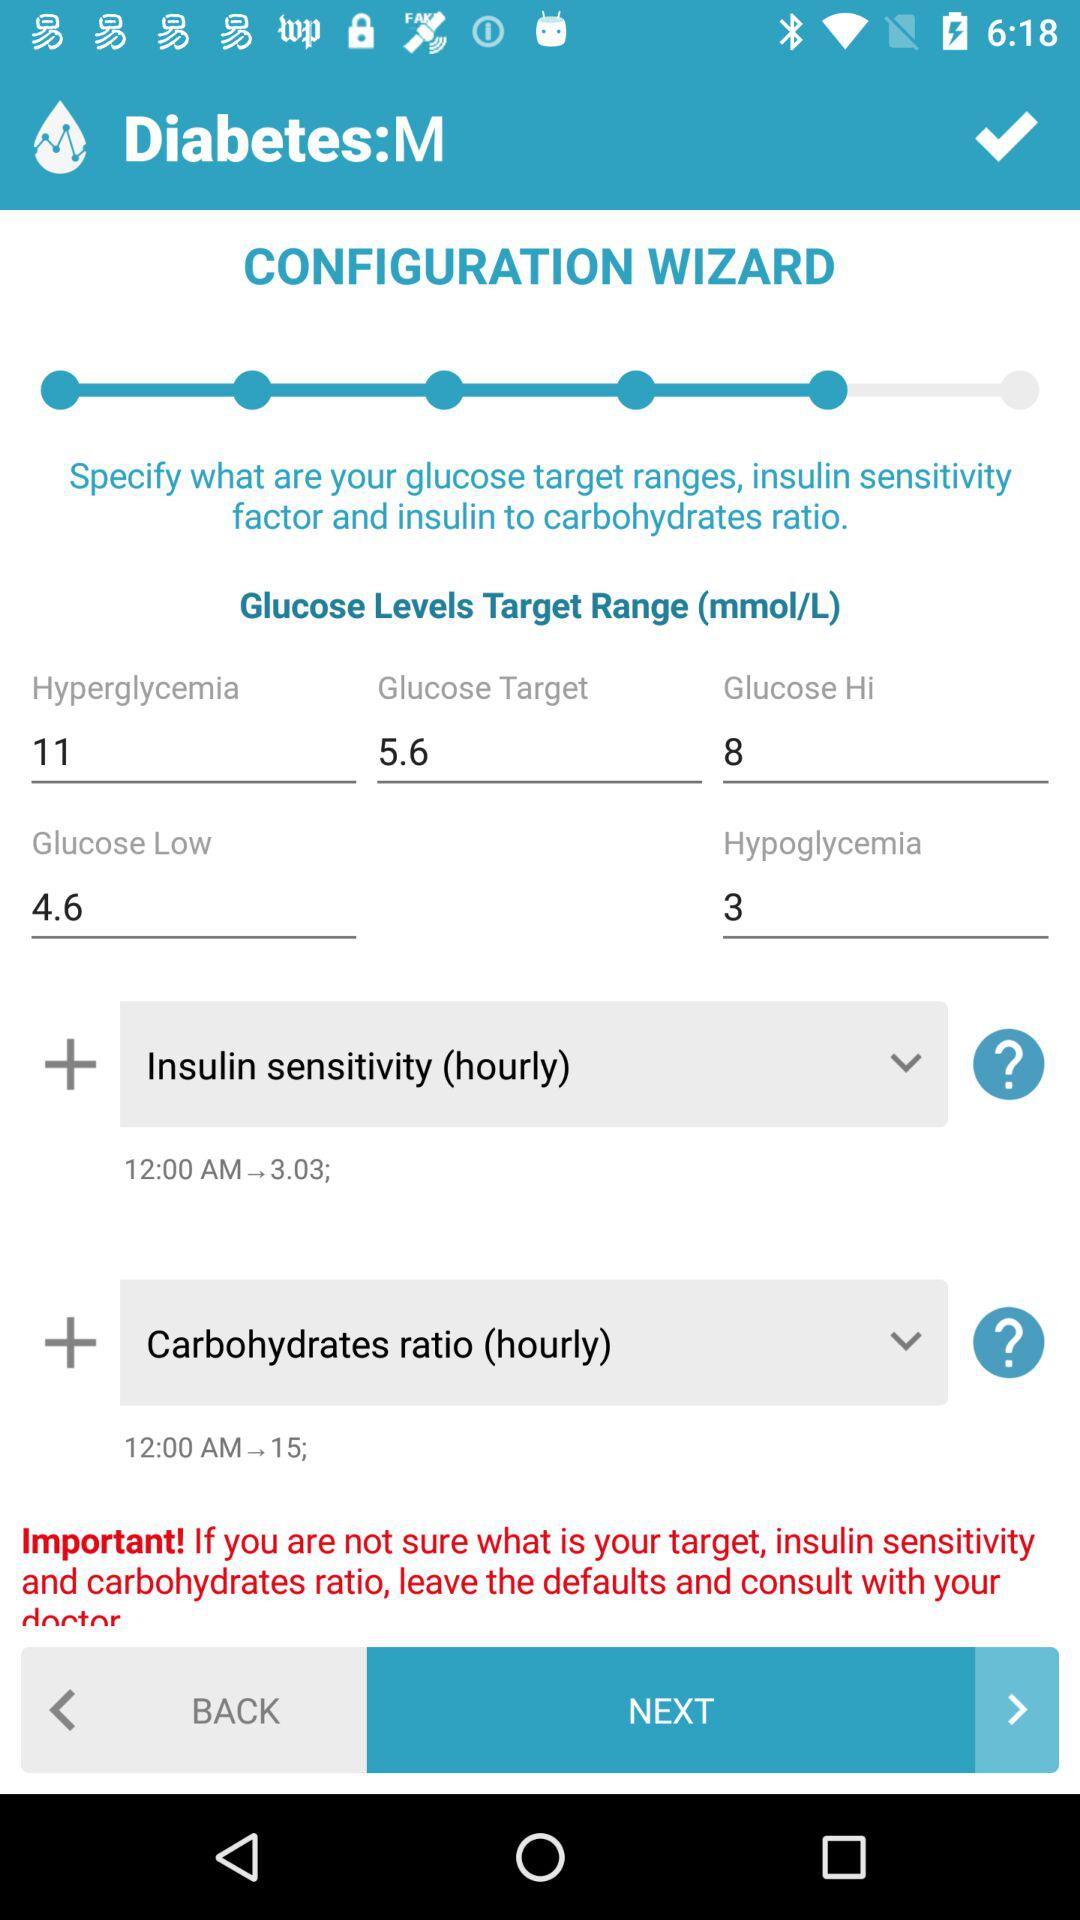What is the glucose low level? The glucose low level is 4.6. 